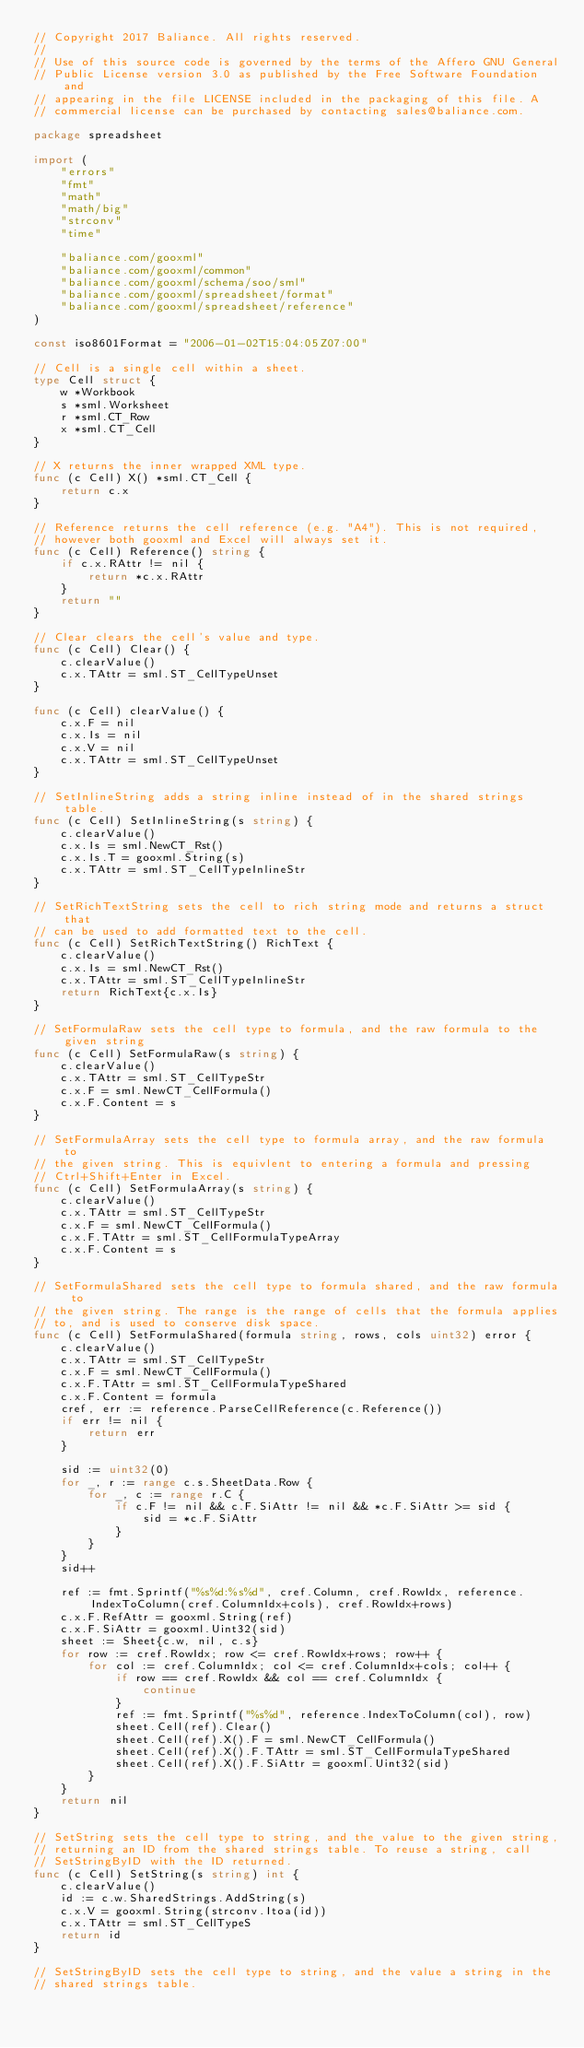Convert code to text. <code><loc_0><loc_0><loc_500><loc_500><_Go_>// Copyright 2017 Baliance. All rights reserved.
//
// Use of this source code is governed by the terms of the Affero GNU General
// Public License version 3.0 as published by the Free Software Foundation and
// appearing in the file LICENSE included in the packaging of this file. A
// commercial license can be purchased by contacting sales@baliance.com.

package spreadsheet

import (
	"errors"
	"fmt"
	"math"
	"math/big"
	"strconv"
	"time"

	"baliance.com/gooxml"
	"baliance.com/gooxml/common"
	"baliance.com/gooxml/schema/soo/sml"
	"baliance.com/gooxml/spreadsheet/format"
	"baliance.com/gooxml/spreadsheet/reference"
)

const iso8601Format = "2006-01-02T15:04:05Z07:00"

// Cell is a single cell within a sheet.
type Cell struct {
	w *Workbook
	s *sml.Worksheet
	r *sml.CT_Row
	x *sml.CT_Cell
}

// X returns the inner wrapped XML type.
func (c Cell) X() *sml.CT_Cell {
	return c.x
}

// Reference returns the cell reference (e.g. "A4"). This is not required,
// however both gooxml and Excel will always set it.
func (c Cell) Reference() string {
	if c.x.RAttr != nil {
		return *c.x.RAttr
	}
	return ""
}

// Clear clears the cell's value and type.
func (c Cell) Clear() {
	c.clearValue()
	c.x.TAttr = sml.ST_CellTypeUnset
}

func (c Cell) clearValue() {
	c.x.F = nil
	c.x.Is = nil
	c.x.V = nil
	c.x.TAttr = sml.ST_CellTypeUnset
}

// SetInlineString adds a string inline instead of in the shared strings table.
func (c Cell) SetInlineString(s string) {
	c.clearValue()
	c.x.Is = sml.NewCT_Rst()
	c.x.Is.T = gooxml.String(s)
	c.x.TAttr = sml.ST_CellTypeInlineStr
}

// SetRichTextString sets the cell to rich string mode and returns a struct that
// can be used to add formatted text to the cell.
func (c Cell) SetRichTextString() RichText {
	c.clearValue()
	c.x.Is = sml.NewCT_Rst()
	c.x.TAttr = sml.ST_CellTypeInlineStr
	return RichText{c.x.Is}
}

// SetFormulaRaw sets the cell type to formula, and the raw formula to the given string
func (c Cell) SetFormulaRaw(s string) {
	c.clearValue()
	c.x.TAttr = sml.ST_CellTypeStr
	c.x.F = sml.NewCT_CellFormula()
	c.x.F.Content = s
}

// SetFormulaArray sets the cell type to formula array, and the raw formula to
// the given string. This is equivlent to entering a formula and pressing
// Ctrl+Shift+Enter in Excel.
func (c Cell) SetFormulaArray(s string) {
	c.clearValue()
	c.x.TAttr = sml.ST_CellTypeStr
	c.x.F = sml.NewCT_CellFormula()
	c.x.F.TAttr = sml.ST_CellFormulaTypeArray
	c.x.F.Content = s
}

// SetFormulaShared sets the cell type to formula shared, and the raw formula to
// the given string. The range is the range of cells that the formula applies
// to, and is used to conserve disk space.
func (c Cell) SetFormulaShared(formula string, rows, cols uint32) error {
	c.clearValue()
	c.x.TAttr = sml.ST_CellTypeStr
	c.x.F = sml.NewCT_CellFormula()
	c.x.F.TAttr = sml.ST_CellFormulaTypeShared
	c.x.F.Content = formula
	cref, err := reference.ParseCellReference(c.Reference())
	if err != nil {
		return err
	}

	sid := uint32(0)
	for _, r := range c.s.SheetData.Row {
		for _, c := range r.C {
			if c.F != nil && c.F.SiAttr != nil && *c.F.SiAttr >= sid {
				sid = *c.F.SiAttr
			}
		}
	}
	sid++

	ref := fmt.Sprintf("%s%d:%s%d", cref.Column, cref.RowIdx, reference.IndexToColumn(cref.ColumnIdx+cols), cref.RowIdx+rows)
	c.x.F.RefAttr = gooxml.String(ref)
	c.x.F.SiAttr = gooxml.Uint32(sid)
	sheet := Sheet{c.w, nil, c.s}
	for row := cref.RowIdx; row <= cref.RowIdx+rows; row++ {
		for col := cref.ColumnIdx; col <= cref.ColumnIdx+cols; col++ {
			if row == cref.RowIdx && col == cref.ColumnIdx {
				continue
			}
			ref := fmt.Sprintf("%s%d", reference.IndexToColumn(col), row)
			sheet.Cell(ref).Clear()
			sheet.Cell(ref).X().F = sml.NewCT_CellFormula()
			sheet.Cell(ref).X().F.TAttr = sml.ST_CellFormulaTypeShared
			sheet.Cell(ref).X().F.SiAttr = gooxml.Uint32(sid)
		}
	}
	return nil
}

// SetString sets the cell type to string, and the value to the given string,
// returning an ID from the shared strings table. To reuse a string, call
// SetStringByID with the ID returned.
func (c Cell) SetString(s string) int {
	c.clearValue()
	id := c.w.SharedStrings.AddString(s)
	c.x.V = gooxml.String(strconv.Itoa(id))
	c.x.TAttr = sml.ST_CellTypeS
	return id
}

// SetStringByID sets the cell type to string, and the value a string in the
// shared strings table.</code> 